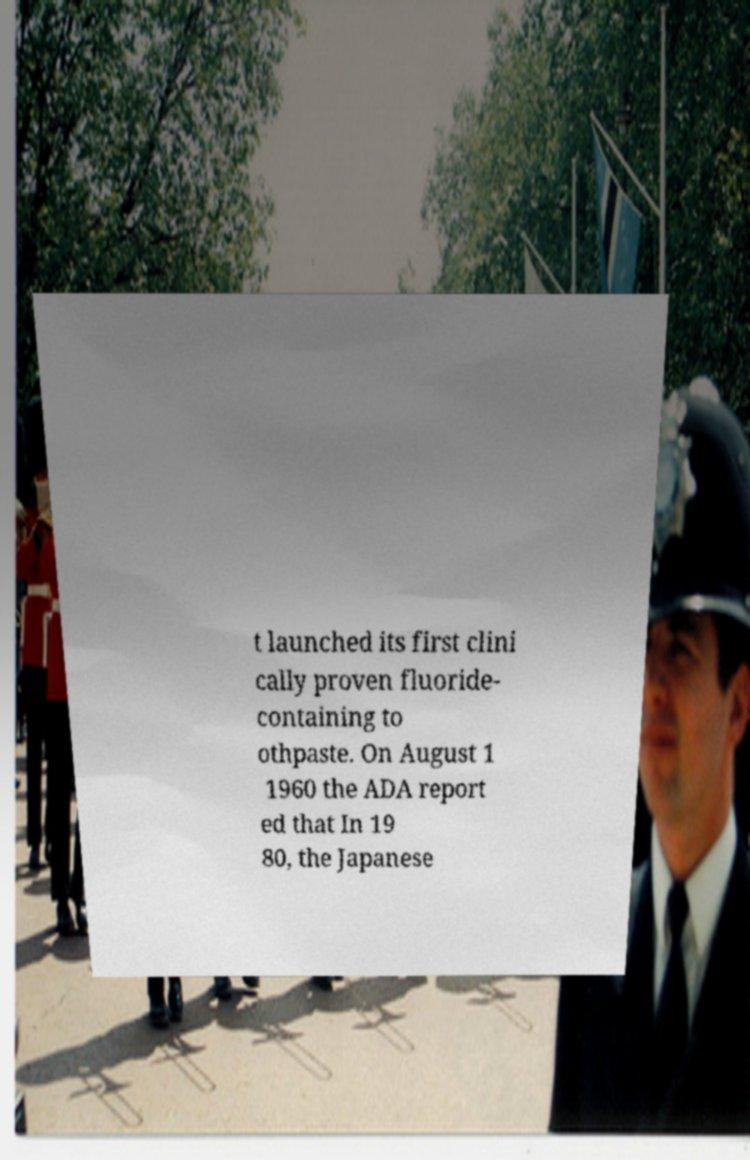Could you extract and type out the text from this image? t launched its first clini cally proven fluoride- containing to othpaste. On August 1 1960 the ADA report ed that In 19 80, the Japanese 